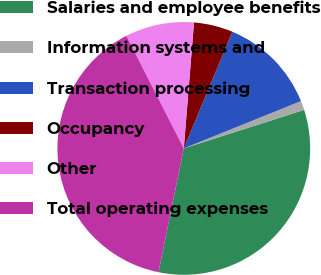Convert chart to OTSL. <chart><loc_0><loc_0><loc_500><loc_500><pie_chart><fcel>Salaries and employee benefits<fcel>Information systems and<fcel>Transaction processing<fcel>Occupancy<fcel>Other<fcel>Total operating expenses<nl><fcel>33.14%<fcel>1.18%<fcel>12.61%<fcel>4.99%<fcel>8.8%<fcel>39.28%<nl></chart> 